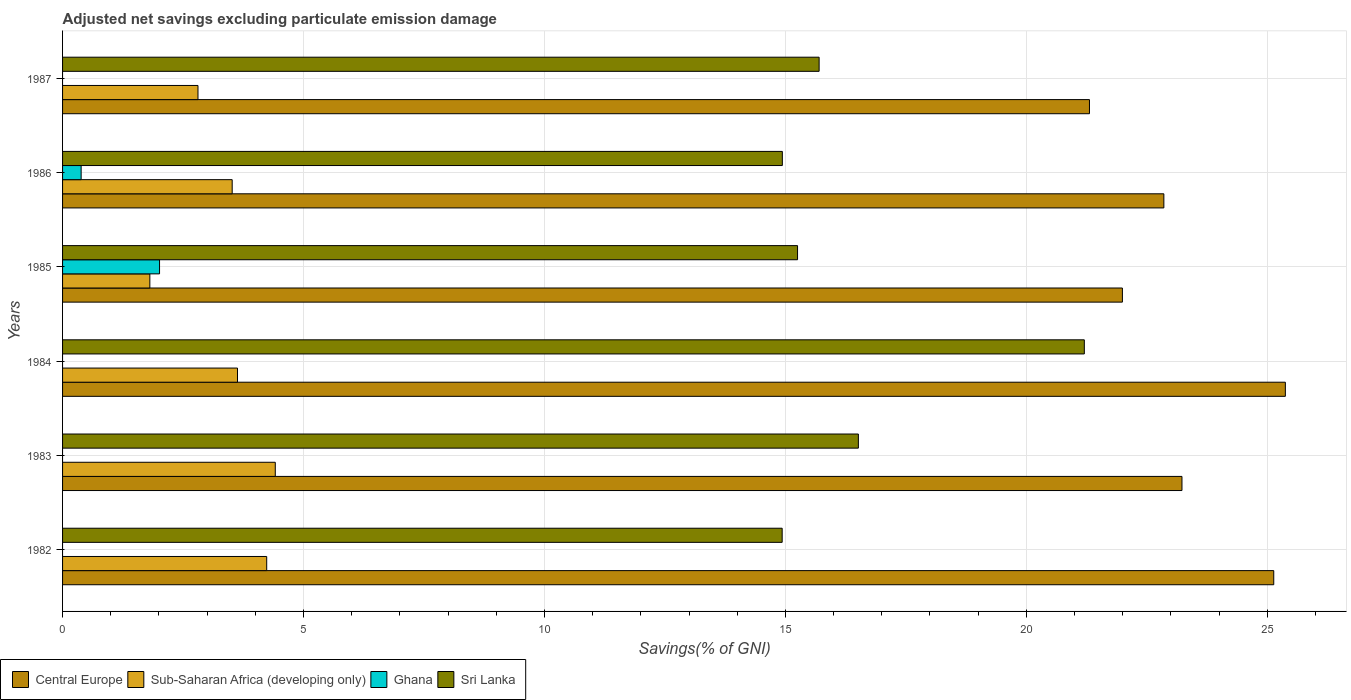How many groups of bars are there?
Make the answer very short. 6. Are the number of bars on each tick of the Y-axis equal?
Your answer should be very brief. No. How many bars are there on the 6th tick from the top?
Provide a succinct answer. 3. How many bars are there on the 5th tick from the bottom?
Your answer should be very brief. 4. What is the adjusted net savings in Sub-Saharan Africa (developing only) in 1984?
Your response must be concise. 3.63. Across all years, what is the maximum adjusted net savings in Central Europe?
Provide a short and direct response. 25.37. Across all years, what is the minimum adjusted net savings in Sri Lanka?
Ensure brevity in your answer.  14.93. What is the total adjusted net savings in Central Europe in the graph?
Your response must be concise. 139.89. What is the difference between the adjusted net savings in Central Europe in 1984 and that in 1986?
Make the answer very short. 2.52. What is the difference between the adjusted net savings in Sri Lanka in 1983 and the adjusted net savings in Ghana in 1984?
Your answer should be compact. 16.51. What is the average adjusted net savings in Central Europe per year?
Provide a short and direct response. 23.32. In the year 1985, what is the difference between the adjusted net savings in Sri Lanka and adjusted net savings in Central Europe?
Your answer should be very brief. -6.74. In how many years, is the adjusted net savings in Sri Lanka greater than 9 %?
Your answer should be very brief. 6. What is the ratio of the adjusted net savings in Central Europe in 1983 to that in 1985?
Keep it short and to the point. 1.06. Is the adjusted net savings in Ghana in 1985 less than that in 1986?
Your response must be concise. No. Is the difference between the adjusted net savings in Sri Lanka in 1982 and 1984 greater than the difference between the adjusted net savings in Central Europe in 1982 and 1984?
Give a very brief answer. No. What is the difference between the highest and the second highest adjusted net savings in Sri Lanka?
Ensure brevity in your answer.  4.69. What is the difference between the highest and the lowest adjusted net savings in Sub-Saharan Africa (developing only)?
Make the answer very short. 2.6. Is the sum of the adjusted net savings in Sub-Saharan Africa (developing only) in 1983 and 1984 greater than the maximum adjusted net savings in Sri Lanka across all years?
Provide a short and direct response. No. Is it the case that in every year, the sum of the adjusted net savings in Central Europe and adjusted net savings in Sri Lanka is greater than the sum of adjusted net savings in Sub-Saharan Africa (developing only) and adjusted net savings in Ghana?
Provide a succinct answer. No. Are the values on the major ticks of X-axis written in scientific E-notation?
Give a very brief answer. No. Does the graph contain grids?
Provide a succinct answer. Yes. How many legend labels are there?
Your response must be concise. 4. How are the legend labels stacked?
Offer a terse response. Horizontal. What is the title of the graph?
Your answer should be very brief. Adjusted net savings excluding particulate emission damage. What is the label or title of the X-axis?
Provide a short and direct response. Savings(% of GNI). What is the label or title of the Y-axis?
Offer a terse response. Years. What is the Savings(% of GNI) in Central Europe in 1982?
Ensure brevity in your answer.  25.13. What is the Savings(% of GNI) in Sub-Saharan Africa (developing only) in 1982?
Ensure brevity in your answer.  4.24. What is the Savings(% of GNI) in Ghana in 1982?
Offer a very short reply. 0. What is the Savings(% of GNI) of Sri Lanka in 1982?
Provide a short and direct response. 14.93. What is the Savings(% of GNI) in Central Europe in 1983?
Keep it short and to the point. 23.23. What is the Savings(% of GNI) of Sub-Saharan Africa (developing only) in 1983?
Give a very brief answer. 4.41. What is the Savings(% of GNI) in Sri Lanka in 1983?
Provide a succinct answer. 16.51. What is the Savings(% of GNI) of Central Europe in 1984?
Your answer should be very brief. 25.37. What is the Savings(% of GNI) of Sub-Saharan Africa (developing only) in 1984?
Your answer should be very brief. 3.63. What is the Savings(% of GNI) of Sri Lanka in 1984?
Offer a very short reply. 21.2. What is the Savings(% of GNI) in Central Europe in 1985?
Provide a succinct answer. 21.99. What is the Savings(% of GNI) of Sub-Saharan Africa (developing only) in 1985?
Provide a short and direct response. 1.81. What is the Savings(% of GNI) of Ghana in 1985?
Your response must be concise. 2.01. What is the Savings(% of GNI) of Sri Lanka in 1985?
Your response must be concise. 15.25. What is the Savings(% of GNI) of Central Europe in 1986?
Your answer should be very brief. 22.85. What is the Savings(% of GNI) of Sub-Saharan Africa (developing only) in 1986?
Offer a terse response. 3.52. What is the Savings(% of GNI) of Ghana in 1986?
Offer a terse response. 0.39. What is the Savings(% of GNI) in Sri Lanka in 1986?
Your answer should be very brief. 14.94. What is the Savings(% of GNI) in Central Europe in 1987?
Make the answer very short. 21.31. What is the Savings(% of GNI) of Sub-Saharan Africa (developing only) in 1987?
Keep it short and to the point. 2.81. What is the Savings(% of GNI) of Ghana in 1987?
Keep it short and to the point. 0. What is the Savings(% of GNI) in Sri Lanka in 1987?
Give a very brief answer. 15.7. Across all years, what is the maximum Savings(% of GNI) in Central Europe?
Offer a terse response. 25.37. Across all years, what is the maximum Savings(% of GNI) in Sub-Saharan Africa (developing only)?
Give a very brief answer. 4.41. Across all years, what is the maximum Savings(% of GNI) of Ghana?
Your response must be concise. 2.01. Across all years, what is the maximum Savings(% of GNI) of Sri Lanka?
Provide a succinct answer. 21.2. Across all years, what is the minimum Savings(% of GNI) of Central Europe?
Offer a very short reply. 21.31. Across all years, what is the minimum Savings(% of GNI) of Sub-Saharan Africa (developing only)?
Offer a very short reply. 1.81. Across all years, what is the minimum Savings(% of GNI) in Ghana?
Provide a short and direct response. 0. Across all years, what is the minimum Savings(% of GNI) of Sri Lanka?
Your answer should be very brief. 14.93. What is the total Savings(% of GNI) in Central Europe in the graph?
Ensure brevity in your answer.  139.89. What is the total Savings(% of GNI) of Sub-Saharan Africa (developing only) in the graph?
Keep it short and to the point. 20.42. What is the total Savings(% of GNI) of Ghana in the graph?
Provide a short and direct response. 2.4. What is the total Savings(% of GNI) in Sri Lanka in the graph?
Provide a short and direct response. 98.54. What is the difference between the Savings(% of GNI) of Central Europe in 1982 and that in 1983?
Provide a short and direct response. 1.9. What is the difference between the Savings(% of GNI) of Sub-Saharan Africa (developing only) in 1982 and that in 1983?
Make the answer very short. -0.18. What is the difference between the Savings(% of GNI) in Sri Lanka in 1982 and that in 1983?
Offer a very short reply. -1.58. What is the difference between the Savings(% of GNI) in Central Europe in 1982 and that in 1984?
Ensure brevity in your answer.  -0.24. What is the difference between the Savings(% of GNI) in Sub-Saharan Africa (developing only) in 1982 and that in 1984?
Your response must be concise. 0.61. What is the difference between the Savings(% of GNI) in Sri Lanka in 1982 and that in 1984?
Ensure brevity in your answer.  -6.27. What is the difference between the Savings(% of GNI) in Central Europe in 1982 and that in 1985?
Provide a succinct answer. 3.14. What is the difference between the Savings(% of GNI) of Sub-Saharan Africa (developing only) in 1982 and that in 1985?
Your answer should be compact. 2.43. What is the difference between the Savings(% of GNI) in Sri Lanka in 1982 and that in 1985?
Provide a short and direct response. -0.32. What is the difference between the Savings(% of GNI) of Central Europe in 1982 and that in 1986?
Offer a very short reply. 2.28. What is the difference between the Savings(% of GNI) in Sub-Saharan Africa (developing only) in 1982 and that in 1986?
Ensure brevity in your answer.  0.72. What is the difference between the Savings(% of GNI) of Sri Lanka in 1982 and that in 1986?
Make the answer very short. -0. What is the difference between the Savings(% of GNI) in Central Europe in 1982 and that in 1987?
Your response must be concise. 3.82. What is the difference between the Savings(% of GNI) in Sub-Saharan Africa (developing only) in 1982 and that in 1987?
Ensure brevity in your answer.  1.43. What is the difference between the Savings(% of GNI) in Sri Lanka in 1982 and that in 1987?
Your answer should be very brief. -0.77. What is the difference between the Savings(% of GNI) of Central Europe in 1983 and that in 1984?
Offer a terse response. -2.15. What is the difference between the Savings(% of GNI) in Sub-Saharan Africa (developing only) in 1983 and that in 1984?
Provide a succinct answer. 0.78. What is the difference between the Savings(% of GNI) in Sri Lanka in 1983 and that in 1984?
Make the answer very short. -4.69. What is the difference between the Savings(% of GNI) of Central Europe in 1983 and that in 1985?
Your answer should be compact. 1.24. What is the difference between the Savings(% of GNI) in Sub-Saharan Africa (developing only) in 1983 and that in 1985?
Keep it short and to the point. 2.6. What is the difference between the Savings(% of GNI) of Sri Lanka in 1983 and that in 1985?
Your answer should be very brief. 1.26. What is the difference between the Savings(% of GNI) in Central Europe in 1983 and that in 1986?
Provide a short and direct response. 0.38. What is the difference between the Savings(% of GNI) of Sub-Saharan Africa (developing only) in 1983 and that in 1986?
Make the answer very short. 0.89. What is the difference between the Savings(% of GNI) in Sri Lanka in 1983 and that in 1986?
Ensure brevity in your answer.  1.58. What is the difference between the Savings(% of GNI) of Central Europe in 1983 and that in 1987?
Provide a succinct answer. 1.92. What is the difference between the Savings(% of GNI) in Sub-Saharan Africa (developing only) in 1983 and that in 1987?
Provide a succinct answer. 1.6. What is the difference between the Savings(% of GNI) of Sri Lanka in 1983 and that in 1987?
Make the answer very short. 0.81. What is the difference between the Savings(% of GNI) of Central Europe in 1984 and that in 1985?
Offer a very short reply. 3.38. What is the difference between the Savings(% of GNI) of Sub-Saharan Africa (developing only) in 1984 and that in 1985?
Provide a succinct answer. 1.82. What is the difference between the Savings(% of GNI) of Sri Lanka in 1984 and that in 1985?
Offer a very short reply. 5.95. What is the difference between the Savings(% of GNI) of Central Europe in 1984 and that in 1986?
Ensure brevity in your answer.  2.52. What is the difference between the Savings(% of GNI) in Sub-Saharan Africa (developing only) in 1984 and that in 1986?
Offer a very short reply. 0.11. What is the difference between the Savings(% of GNI) of Sri Lanka in 1984 and that in 1986?
Offer a very short reply. 6.27. What is the difference between the Savings(% of GNI) in Central Europe in 1984 and that in 1987?
Provide a succinct answer. 4.06. What is the difference between the Savings(% of GNI) in Sub-Saharan Africa (developing only) in 1984 and that in 1987?
Make the answer very short. 0.82. What is the difference between the Savings(% of GNI) in Sri Lanka in 1984 and that in 1987?
Provide a short and direct response. 5.5. What is the difference between the Savings(% of GNI) of Central Europe in 1985 and that in 1986?
Make the answer very short. -0.86. What is the difference between the Savings(% of GNI) in Sub-Saharan Africa (developing only) in 1985 and that in 1986?
Your response must be concise. -1.71. What is the difference between the Savings(% of GNI) of Ghana in 1985 and that in 1986?
Your response must be concise. 1.63. What is the difference between the Savings(% of GNI) in Sri Lanka in 1985 and that in 1986?
Offer a terse response. 0.32. What is the difference between the Savings(% of GNI) in Central Europe in 1985 and that in 1987?
Keep it short and to the point. 0.68. What is the difference between the Savings(% of GNI) of Sub-Saharan Africa (developing only) in 1985 and that in 1987?
Your response must be concise. -1. What is the difference between the Savings(% of GNI) in Sri Lanka in 1985 and that in 1987?
Make the answer very short. -0.45. What is the difference between the Savings(% of GNI) of Central Europe in 1986 and that in 1987?
Give a very brief answer. 1.54. What is the difference between the Savings(% of GNI) of Sub-Saharan Africa (developing only) in 1986 and that in 1987?
Provide a succinct answer. 0.71. What is the difference between the Savings(% of GNI) in Sri Lanka in 1986 and that in 1987?
Give a very brief answer. -0.76. What is the difference between the Savings(% of GNI) of Central Europe in 1982 and the Savings(% of GNI) of Sub-Saharan Africa (developing only) in 1983?
Your response must be concise. 20.72. What is the difference between the Savings(% of GNI) of Central Europe in 1982 and the Savings(% of GNI) of Sri Lanka in 1983?
Your answer should be compact. 8.62. What is the difference between the Savings(% of GNI) in Sub-Saharan Africa (developing only) in 1982 and the Savings(% of GNI) in Sri Lanka in 1983?
Give a very brief answer. -12.28. What is the difference between the Savings(% of GNI) in Central Europe in 1982 and the Savings(% of GNI) in Sub-Saharan Africa (developing only) in 1984?
Give a very brief answer. 21.5. What is the difference between the Savings(% of GNI) in Central Europe in 1982 and the Savings(% of GNI) in Sri Lanka in 1984?
Your answer should be compact. 3.93. What is the difference between the Savings(% of GNI) in Sub-Saharan Africa (developing only) in 1982 and the Savings(% of GNI) in Sri Lanka in 1984?
Give a very brief answer. -16.97. What is the difference between the Savings(% of GNI) in Central Europe in 1982 and the Savings(% of GNI) in Sub-Saharan Africa (developing only) in 1985?
Your response must be concise. 23.32. What is the difference between the Savings(% of GNI) in Central Europe in 1982 and the Savings(% of GNI) in Ghana in 1985?
Offer a very short reply. 23.12. What is the difference between the Savings(% of GNI) of Central Europe in 1982 and the Savings(% of GNI) of Sri Lanka in 1985?
Provide a succinct answer. 9.88. What is the difference between the Savings(% of GNI) in Sub-Saharan Africa (developing only) in 1982 and the Savings(% of GNI) in Ghana in 1985?
Offer a terse response. 2.22. What is the difference between the Savings(% of GNI) of Sub-Saharan Africa (developing only) in 1982 and the Savings(% of GNI) of Sri Lanka in 1985?
Offer a terse response. -11.02. What is the difference between the Savings(% of GNI) of Central Europe in 1982 and the Savings(% of GNI) of Sub-Saharan Africa (developing only) in 1986?
Your response must be concise. 21.61. What is the difference between the Savings(% of GNI) of Central Europe in 1982 and the Savings(% of GNI) of Ghana in 1986?
Make the answer very short. 24.75. What is the difference between the Savings(% of GNI) of Central Europe in 1982 and the Savings(% of GNI) of Sri Lanka in 1986?
Offer a very short reply. 10.2. What is the difference between the Savings(% of GNI) in Sub-Saharan Africa (developing only) in 1982 and the Savings(% of GNI) in Ghana in 1986?
Your answer should be compact. 3.85. What is the difference between the Savings(% of GNI) of Sub-Saharan Africa (developing only) in 1982 and the Savings(% of GNI) of Sri Lanka in 1986?
Offer a terse response. -10.7. What is the difference between the Savings(% of GNI) of Central Europe in 1982 and the Savings(% of GNI) of Sub-Saharan Africa (developing only) in 1987?
Keep it short and to the point. 22.32. What is the difference between the Savings(% of GNI) in Central Europe in 1982 and the Savings(% of GNI) in Sri Lanka in 1987?
Ensure brevity in your answer.  9.43. What is the difference between the Savings(% of GNI) of Sub-Saharan Africa (developing only) in 1982 and the Savings(% of GNI) of Sri Lanka in 1987?
Your response must be concise. -11.46. What is the difference between the Savings(% of GNI) in Central Europe in 1983 and the Savings(% of GNI) in Sub-Saharan Africa (developing only) in 1984?
Your answer should be compact. 19.6. What is the difference between the Savings(% of GNI) of Central Europe in 1983 and the Savings(% of GNI) of Sri Lanka in 1984?
Provide a short and direct response. 2.03. What is the difference between the Savings(% of GNI) in Sub-Saharan Africa (developing only) in 1983 and the Savings(% of GNI) in Sri Lanka in 1984?
Provide a short and direct response. -16.79. What is the difference between the Savings(% of GNI) of Central Europe in 1983 and the Savings(% of GNI) of Sub-Saharan Africa (developing only) in 1985?
Ensure brevity in your answer.  21.42. What is the difference between the Savings(% of GNI) in Central Europe in 1983 and the Savings(% of GNI) in Ghana in 1985?
Offer a very short reply. 21.22. What is the difference between the Savings(% of GNI) of Central Europe in 1983 and the Savings(% of GNI) of Sri Lanka in 1985?
Offer a terse response. 7.98. What is the difference between the Savings(% of GNI) in Sub-Saharan Africa (developing only) in 1983 and the Savings(% of GNI) in Ghana in 1985?
Offer a very short reply. 2.4. What is the difference between the Savings(% of GNI) of Sub-Saharan Africa (developing only) in 1983 and the Savings(% of GNI) of Sri Lanka in 1985?
Make the answer very short. -10.84. What is the difference between the Savings(% of GNI) in Central Europe in 1983 and the Savings(% of GNI) in Sub-Saharan Africa (developing only) in 1986?
Offer a terse response. 19.71. What is the difference between the Savings(% of GNI) in Central Europe in 1983 and the Savings(% of GNI) in Ghana in 1986?
Offer a terse response. 22.84. What is the difference between the Savings(% of GNI) in Central Europe in 1983 and the Savings(% of GNI) in Sri Lanka in 1986?
Give a very brief answer. 8.29. What is the difference between the Savings(% of GNI) in Sub-Saharan Africa (developing only) in 1983 and the Savings(% of GNI) in Ghana in 1986?
Offer a terse response. 4.03. What is the difference between the Savings(% of GNI) of Sub-Saharan Africa (developing only) in 1983 and the Savings(% of GNI) of Sri Lanka in 1986?
Keep it short and to the point. -10.52. What is the difference between the Savings(% of GNI) of Central Europe in 1983 and the Savings(% of GNI) of Sub-Saharan Africa (developing only) in 1987?
Your answer should be compact. 20.42. What is the difference between the Savings(% of GNI) of Central Europe in 1983 and the Savings(% of GNI) of Sri Lanka in 1987?
Keep it short and to the point. 7.53. What is the difference between the Savings(% of GNI) of Sub-Saharan Africa (developing only) in 1983 and the Savings(% of GNI) of Sri Lanka in 1987?
Your answer should be very brief. -11.29. What is the difference between the Savings(% of GNI) of Central Europe in 1984 and the Savings(% of GNI) of Sub-Saharan Africa (developing only) in 1985?
Your answer should be compact. 23.56. What is the difference between the Savings(% of GNI) of Central Europe in 1984 and the Savings(% of GNI) of Ghana in 1985?
Ensure brevity in your answer.  23.36. What is the difference between the Savings(% of GNI) of Central Europe in 1984 and the Savings(% of GNI) of Sri Lanka in 1985?
Provide a short and direct response. 10.12. What is the difference between the Savings(% of GNI) in Sub-Saharan Africa (developing only) in 1984 and the Savings(% of GNI) in Ghana in 1985?
Provide a succinct answer. 1.62. What is the difference between the Savings(% of GNI) of Sub-Saharan Africa (developing only) in 1984 and the Savings(% of GNI) of Sri Lanka in 1985?
Your answer should be compact. -11.62. What is the difference between the Savings(% of GNI) of Central Europe in 1984 and the Savings(% of GNI) of Sub-Saharan Africa (developing only) in 1986?
Make the answer very short. 21.85. What is the difference between the Savings(% of GNI) in Central Europe in 1984 and the Savings(% of GNI) in Ghana in 1986?
Offer a very short reply. 24.99. What is the difference between the Savings(% of GNI) in Central Europe in 1984 and the Savings(% of GNI) in Sri Lanka in 1986?
Offer a terse response. 10.44. What is the difference between the Savings(% of GNI) in Sub-Saharan Africa (developing only) in 1984 and the Savings(% of GNI) in Ghana in 1986?
Ensure brevity in your answer.  3.24. What is the difference between the Savings(% of GNI) of Sub-Saharan Africa (developing only) in 1984 and the Savings(% of GNI) of Sri Lanka in 1986?
Your answer should be very brief. -11.31. What is the difference between the Savings(% of GNI) in Central Europe in 1984 and the Savings(% of GNI) in Sub-Saharan Africa (developing only) in 1987?
Offer a terse response. 22.56. What is the difference between the Savings(% of GNI) of Central Europe in 1984 and the Savings(% of GNI) of Sri Lanka in 1987?
Provide a short and direct response. 9.68. What is the difference between the Savings(% of GNI) in Sub-Saharan Africa (developing only) in 1984 and the Savings(% of GNI) in Sri Lanka in 1987?
Make the answer very short. -12.07. What is the difference between the Savings(% of GNI) of Central Europe in 1985 and the Savings(% of GNI) of Sub-Saharan Africa (developing only) in 1986?
Keep it short and to the point. 18.47. What is the difference between the Savings(% of GNI) in Central Europe in 1985 and the Savings(% of GNI) in Ghana in 1986?
Give a very brief answer. 21.61. What is the difference between the Savings(% of GNI) of Central Europe in 1985 and the Savings(% of GNI) of Sri Lanka in 1986?
Offer a very short reply. 7.06. What is the difference between the Savings(% of GNI) in Sub-Saharan Africa (developing only) in 1985 and the Savings(% of GNI) in Ghana in 1986?
Provide a succinct answer. 1.43. What is the difference between the Savings(% of GNI) in Sub-Saharan Africa (developing only) in 1985 and the Savings(% of GNI) in Sri Lanka in 1986?
Your answer should be very brief. -13.13. What is the difference between the Savings(% of GNI) of Ghana in 1985 and the Savings(% of GNI) of Sri Lanka in 1986?
Ensure brevity in your answer.  -12.92. What is the difference between the Savings(% of GNI) of Central Europe in 1985 and the Savings(% of GNI) of Sub-Saharan Africa (developing only) in 1987?
Your answer should be compact. 19.18. What is the difference between the Savings(% of GNI) of Central Europe in 1985 and the Savings(% of GNI) of Sri Lanka in 1987?
Your response must be concise. 6.29. What is the difference between the Savings(% of GNI) of Sub-Saharan Africa (developing only) in 1985 and the Savings(% of GNI) of Sri Lanka in 1987?
Keep it short and to the point. -13.89. What is the difference between the Savings(% of GNI) in Ghana in 1985 and the Savings(% of GNI) in Sri Lanka in 1987?
Offer a terse response. -13.69. What is the difference between the Savings(% of GNI) of Central Europe in 1986 and the Savings(% of GNI) of Sub-Saharan Africa (developing only) in 1987?
Offer a very short reply. 20.04. What is the difference between the Savings(% of GNI) in Central Europe in 1986 and the Savings(% of GNI) in Sri Lanka in 1987?
Your response must be concise. 7.15. What is the difference between the Savings(% of GNI) of Sub-Saharan Africa (developing only) in 1986 and the Savings(% of GNI) of Sri Lanka in 1987?
Give a very brief answer. -12.18. What is the difference between the Savings(% of GNI) of Ghana in 1986 and the Savings(% of GNI) of Sri Lanka in 1987?
Your answer should be very brief. -15.31. What is the average Savings(% of GNI) of Central Europe per year?
Your response must be concise. 23.32. What is the average Savings(% of GNI) of Sub-Saharan Africa (developing only) per year?
Provide a succinct answer. 3.4. What is the average Savings(% of GNI) in Ghana per year?
Ensure brevity in your answer.  0.4. What is the average Savings(% of GNI) in Sri Lanka per year?
Provide a short and direct response. 16.42. In the year 1982, what is the difference between the Savings(% of GNI) of Central Europe and Savings(% of GNI) of Sub-Saharan Africa (developing only)?
Offer a terse response. 20.9. In the year 1982, what is the difference between the Savings(% of GNI) of Central Europe and Savings(% of GNI) of Sri Lanka?
Your response must be concise. 10.2. In the year 1982, what is the difference between the Savings(% of GNI) of Sub-Saharan Africa (developing only) and Savings(% of GNI) of Sri Lanka?
Give a very brief answer. -10.7. In the year 1983, what is the difference between the Savings(% of GNI) of Central Europe and Savings(% of GNI) of Sub-Saharan Africa (developing only)?
Your response must be concise. 18.81. In the year 1983, what is the difference between the Savings(% of GNI) in Central Europe and Savings(% of GNI) in Sri Lanka?
Keep it short and to the point. 6.71. In the year 1984, what is the difference between the Savings(% of GNI) of Central Europe and Savings(% of GNI) of Sub-Saharan Africa (developing only)?
Give a very brief answer. 21.74. In the year 1984, what is the difference between the Savings(% of GNI) in Central Europe and Savings(% of GNI) in Sri Lanka?
Ensure brevity in your answer.  4.17. In the year 1984, what is the difference between the Savings(% of GNI) of Sub-Saharan Africa (developing only) and Savings(% of GNI) of Sri Lanka?
Provide a short and direct response. -17.57. In the year 1985, what is the difference between the Savings(% of GNI) in Central Europe and Savings(% of GNI) in Sub-Saharan Africa (developing only)?
Provide a short and direct response. 20.18. In the year 1985, what is the difference between the Savings(% of GNI) of Central Europe and Savings(% of GNI) of Ghana?
Ensure brevity in your answer.  19.98. In the year 1985, what is the difference between the Savings(% of GNI) of Central Europe and Savings(% of GNI) of Sri Lanka?
Your answer should be very brief. 6.74. In the year 1985, what is the difference between the Savings(% of GNI) in Sub-Saharan Africa (developing only) and Savings(% of GNI) in Ghana?
Your response must be concise. -0.2. In the year 1985, what is the difference between the Savings(% of GNI) in Sub-Saharan Africa (developing only) and Savings(% of GNI) in Sri Lanka?
Keep it short and to the point. -13.44. In the year 1985, what is the difference between the Savings(% of GNI) of Ghana and Savings(% of GNI) of Sri Lanka?
Give a very brief answer. -13.24. In the year 1986, what is the difference between the Savings(% of GNI) in Central Europe and Savings(% of GNI) in Sub-Saharan Africa (developing only)?
Provide a succinct answer. 19.33. In the year 1986, what is the difference between the Savings(% of GNI) of Central Europe and Savings(% of GNI) of Ghana?
Offer a very short reply. 22.47. In the year 1986, what is the difference between the Savings(% of GNI) in Central Europe and Savings(% of GNI) in Sri Lanka?
Offer a terse response. 7.92. In the year 1986, what is the difference between the Savings(% of GNI) of Sub-Saharan Africa (developing only) and Savings(% of GNI) of Ghana?
Give a very brief answer. 3.13. In the year 1986, what is the difference between the Savings(% of GNI) of Sub-Saharan Africa (developing only) and Savings(% of GNI) of Sri Lanka?
Your answer should be very brief. -11.42. In the year 1986, what is the difference between the Savings(% of GNI) in Ghana and Savings(% of GNI) in Sri Lanka?
Offer a terse response. -14.55. In the year 1987, what is the difference between the Savings(% of GNI) of Central Europe and Savings(% of GNI) of Sub-Saharan Africa (developing only)?
Provide a succinct answer. 18.5. In the year 1987, what is the difference between the Savings(% of GNI) of Central Europe and Savings(% of GNI) of Sri Lanka?
Offer a very short reply. 5.61. In the year 1987, what is the difference between the Savings(% of GNI) of Sub-Saharan Africa (developing only) and Savings(% of GNI) of Sri Lanka?
Your answer should be compact. -12.89. What is the ratio of the Savings(% of GNI) in Central Europe in 1982 to that in 1983?
Keep it short and to the point. 1.08. What is the ratio of the Savings(% of GNI) of Sub-Saharan Africa (developing only) in 1982 to that in 1983?
Offer a terse response. 0.96. What is the ratio of the Savings(% of GNI) in Sri Lanka in 1982 to that in 1983?
Offer a terse response. 0.9. What is the ratio of the Savings(% of GNI) of Sub-Saharan Africa (developing only) in 1982 to that in 1984?
Your response must be concise. 1.17. What is the ratio of the Savings(% of GNI) in Sri Lanka in 1982 to that in 1984?
Your answer should be very brief. 0.7. What is the ratio of the Savings(% of GNI) of Central Europe in 1982 to that in 1985?
Your response must be concise. 1.14. What is the ratio of the Savings(% of GNI) of Sub-Saharan Africa (developing only) in 1982 to that in 1985?
Ensure brevity in your answer.  2.34. What is the ratio of the Savings(% of GNI) in Sri Lanka in 1982 to that in 1985?
Provide a short and direct response. 0.98. What is the ratio of the Savings(% of GNI) of Central Europe in 1982 to that in 1986?
Give a very brief answer. 1.1. What is the ratio of the Savings(% of GNI) of Sub-Saharan Africa (developing only) in 1982 to that in 1986?
Offer a very short reply. 1.2. What is the ratio of the Savings(% of GNI) in Sri Lanka in 1982 to that in 1986?
Your answer should be compact. 1. What is the ratio of the Savings(% of GNI) of Central Europe in 1982 to that in 1987?
Your answer should be very brief. 1.18. What is the ratio of the Savings(% of GNI) in Sub-Saharan Africa (developing only) in 1982 to that in 1987?
Your answer should be compact. 1.51. What is the ratio of the Savings(% of GNI) of Sri Lanka in 1982 to that in 1987?
Offer a terse response. 0.95. What is the ratio of the Savings(% of GNI) of Central Europe in 1983 to that in 1984?
Your answer should be very brief. 0.92. What is the ratio of the Savings(% of GNI) of Sub-Saharan Africa (developing only) in 1983 to that in 1984?
Give a very brief answer. 1.22. What is the ratio of the Savings(% of GNI) in Sri Lanka in 1983 to that in 1984?
Your answer should be very brief. 0.78. What is the ratio of the Savings(% of GNI) of Central Europe in 1983 to that in 1985?
Keep it short and to the point. 1.06. What is the ratio of the Savings(% of GNI) in Sub-Saharan Africa (developing only) in 1983 to that in 1985?
Your answer should be compact. 2.44. What is the ratio of the Savings(% of GNI) in Sri Lanka in 1983 to that in 1985?
Make the answer very short. 1.08. What is the ratio of the Savings(% of GNI) of Central Europe in 1983 to that in 1986?
Your answer should be compact. 1.02. What is the ratio of the Savings(% of GNI) of Sub-Saharan Africa (developing only) in 1983 to that in 1986?
Provide a short and direct response. 1.25. What is the ratio of the Savings(% of GNI) of Sri Lanka in 1983 to that in 1986?
Offer a terse response. 1.11. What is the ratio of the Savings(% of GNI) of Central Europe in 1983 to that in 1987?
Give a very brief answer. 1.09. What is the ratio of the Savings(% of GNI) in Sub-Saharan Africa (developing only) in 1983 to that in 1987?
Keep it short and to the point. 1.57. What is the ratio of the Savings(% of GNI) of Sri Lanka in 1983 to that in 1987?
Your answer should be compact. 1.05. What is the ratio of the Savings(% of GNI) in Central Europe in 1984 to that in 1985?
Provide a succinct answer. 1.15. What is the ratio of the Savings(% of GNI) in Sub-Saharan Africa (developing only) in 1984 to that in 1985?
Offer a very short reply. 2. What is the ratio of the Savings(% of GNI) of Sri Lanka in 1984 to that in 1985?
Ensure brevity in your answer.  1.39. What is the ratio of the Savings(% of GNI) in Central Europe in 1984 to that in 1986?
Keep it short and to the point. 1.11. What is the ratio of the Savings(% of GNI) in Sub-Saharan Africa (developing only) in 1984 to that in 1986?
Offer a very short reply. 1.03. What is the ratio of the Savings(% of GNI) of Sri Lanka in 1984 to that in 1986?
Make the answer very short. 1.42. What is the ratio of the Savings(% of GNI) in Central Europe in 1984 to that in 1987?
Your answer should be compact. 1.19. What is the ratio of the Savings(% of GNI) in Sub-Saharan Africa (developing only) in 1984 to that in 1987?
Provide a short and direct response. 1.29. What is the ratio of the Savings(% of GNI) in Sri Lanka in 1984 to that in 1987?
Provide a short and direct response. 1.35. What is the ratio of the Savings(% of GNI) in Central Europe in 1985 to that in 1986?
Keep it short and to the point. 0.96. What is the ratio of the Savings(% of GNI) of Sub-Saharan Africa (developing only) in 1985 to that in 1986?
Make the answer very short. 0.51. What is the ratio of the Savings(% of GNI) of Ghana in 1985 to that in 1986?
Give a very brief answer. 5.22. What is the ratio of the Savings(% of GNI) in Sri Lanka in 1985 to that in 1986?
Your answer should be very brief. 1.02. What is the ratio of the Savings(% of GNI) of Central Europe in 1985 to that in 1987?
Your answer should be very brief. 1.03. What is the ratio of the Savings(% of GNI) in Sub-Saharan Africa (developing only) in 1985 to that in 1987?
Ensure brevity in your answer.  0.64. What is the ratio of the Savings(% of GNI) in Sri Lanka in 1985 to that in 1987?
Your answer should be compact. 0.97. What is the ratio of the Savings(% of GNI) in Central Europe in 1986 to that in 1987?
Offer a terse response. 1.07. What is the ratio of the Savings(% of GNI) in Sub-Saharan Africa (developing only) in 1986 to that in 1987?
Your answer should be compact. 1.25. What is the ratio of the Savings(% of GNI) in Sri Lanka in 1986 to that in 1987?
Your response must be concise. 0.95. What is the difference between the highest and the second highest Savings(% of GNI) in Central Europe?
Keep it short and to the point. 0.24. What is the difference between the highest and the second highest Savings(% of GNI) of Sub-Saharan Africa (developing only)?
Your answer should be compact. 0.18. What is the difference between the highest and the second highest Savings(% of GNI) of Sri Lanka?
Your response must be concise. 4.69. What is the difference between the highest and the lowest Savings(% of GNI) in Central Europe?
Offer a very short reply. 4.06. What is the difference between the highest and the lowest Savings(% of GNI) of Sub-Saharan Africa (developing only)?
Offer a very short reply. 2.6. What is the difference between the highest and the lowest Savings(% of GNI) in Ghana?
Make the answer very short. 2.01. What is the difference between the highest and the lowest Savings(% of GNI) of Sri Lanka?
Offer a very short reply. 6.27. 